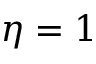Convert formula to latex. <formula><loc_0><loc_0><loc_500><loc_500>\eta = 1</formula> 